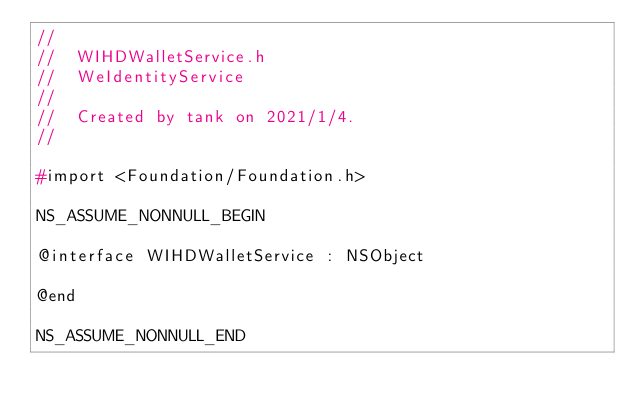<code> <loc_0><loc_0><loc_500><loc_500><_C_>//
//  WIHDWalletService.h
//  WeIdentityService
//
//  Created by tank on 2021/1/4.
//

#import <Foundation/Foundation.h>

NS_ASSUME_NONNULL_BEGIN

@interface WIHDWalletService : NSObject

@end

NS_ASSUME_NONNULL_END
</code> 